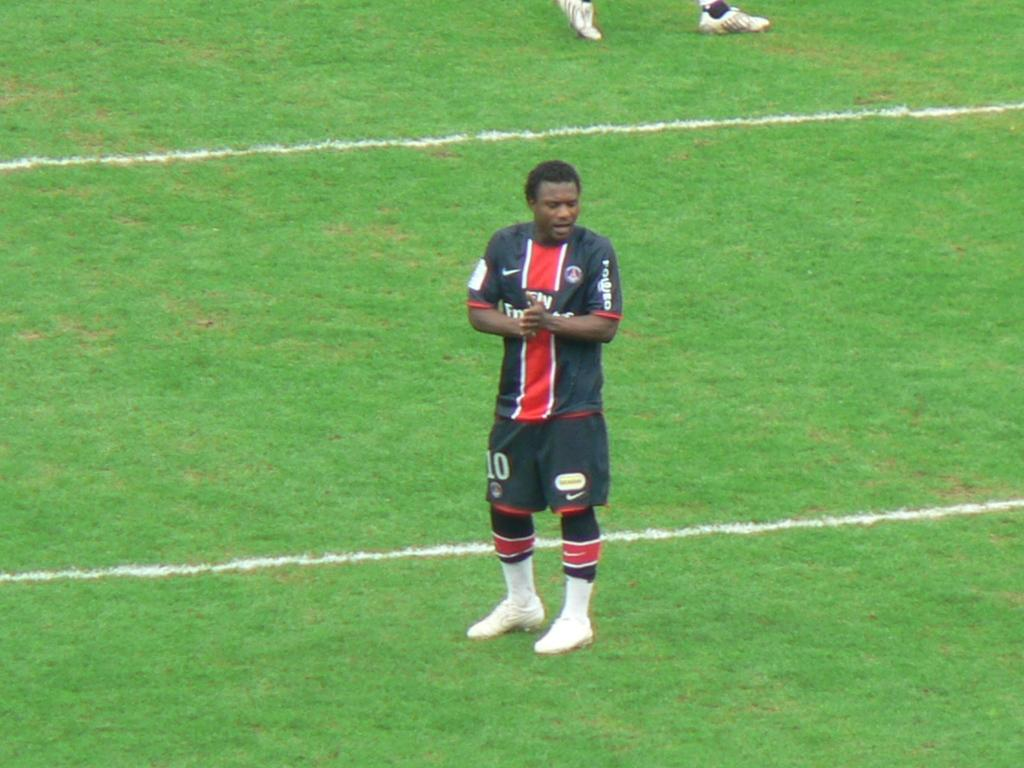<image>
Share a concise interpretation of the image provided. Player number 10 stands on the field speaking to someone. 